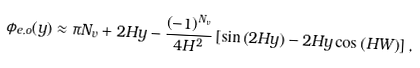Convert formula to latex. <formula><loc_0><loc_0><loc_500><loc_500>\phi _ { e , o } ( y ) \approx \pi N _ { v } + 2 H y - \frac { \left ( - 1 \right ) ^ { N _ { v } } } { 4 H ^ { 2 } } \left [ \sin \left ( 2 H y \right ) - 2 H y \cos \left ( H W \right ) \right ] ,</formula> 